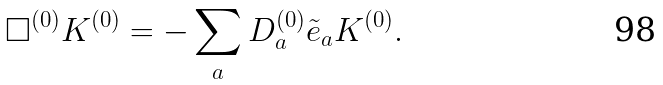<formula> <loc_0><loc_0><loc_500><loc_500>\Box ^ { ( 0 ) } K ^ { ( 0 ) } = - \sum _ { a } D _ { a } ^ { ( 0 ) } \tilde { e } _ { a } K ^ { ( 0 ) } .</formula> 